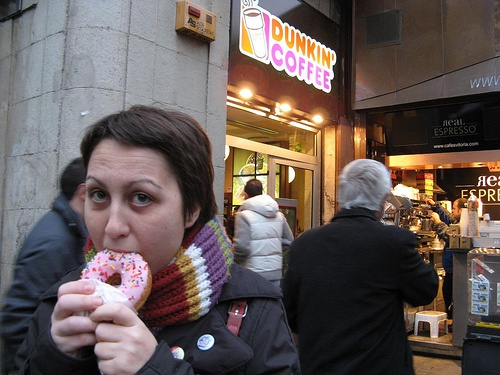Describe the objects in this image and their specific colors. I can see people in black, darkgray, and gray tones, people in black, gray, and darkgray tones, people in black, gray, and darkblue tones, people in black, darkgray, lightgray, and gray tones, and donut in black, lavender, pink, lightpink, and maroon tones in this image. 